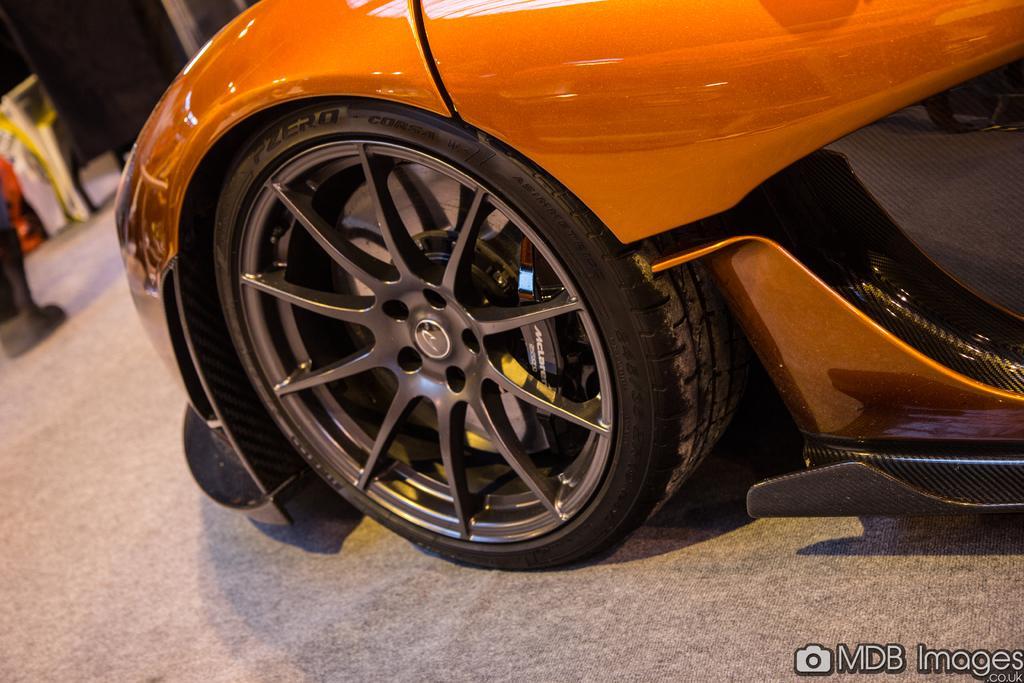Can you describe this image briefly? In the picture I can see an orange car where I can see the tire with a wheel alloy. The background of the image is slightly blurred, where we can see a few objects and here we can see the watermark at the bottom right side of the image. 